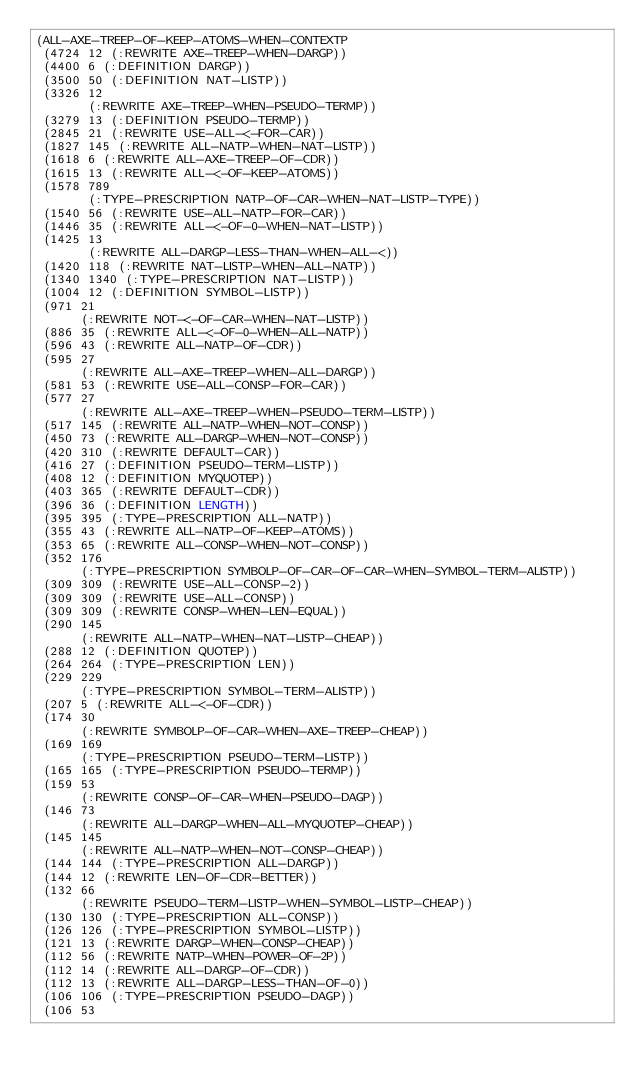Convert code to text. <code><loc_0><loc_0><loc_500><loc_500><_Lisp_>(ALL-AXE-TREEP-OF-KEEP-ATOMS-WHEN-CONTEXTP
 (4724 12 (:REWRITE AXE-TREEP-WHEN-DARGP))
 (4400 6 (:DEFINITION DARGP))
 (3500 50 (:DEFINITION NAT-LISTP))
 (3326 12
       (:REWRITE AXE-TREEP-WHEN-PSEUDO-TERMP))
 (3279 13 (:DEFINITION PSEUDO-TERMP))
 (2845 21 (:REWRITE USE-ALL-<-FOR-CAR))
 (1827 145 (:REWRITE ALL-NATP-WHEN-NAT-LISTP))
 (1618 6 (:REWRITE ALL-AXE-TREEP-OF-CDR))
 (1615 13 (:REWRITE ALL-<-OF-KEEP-ATOMS))
 (1578 789
       (:TYPE-PRESCRIPTION NATP-OF-CAR-WHEN-NAT-LISTP-TYPE))
 (1540 56 (:REWRITE USE-ALL-NATP-FOR-CAR))
 (1446 35 (:REWRITE ALL-<-OF-0-WHEN-NAT-LISTP))
 (1425 13
       (:REWRITE ALL-DARGP-LESS-THAN-WHEN-ALL-<))
 (1420 118 (:REWRITE NAT-LISTP-WHEN-ALL-NATP))
 (1340 1340 (:TYPE-PRESCRIPTION NAT-LISTP))
 (1004 12 (:DEFINITION SYMBOL-LISTP))
 (971 21
      (:REWRITE NOT-<-OF-CAR-WHEN-NAT-LISTP))
 (886 35 (:REWRITE ALL-<-OF-0-WHEN-ALL-NATP))
 (596 43 (:REWRITE ALL-NATP-OF-CDR))
 (595 27
      (:REWRITE ALL-AXE-TREEP-WHEN-ALL-DARGP))
 (581 53 (:REWRITE USE-ALL-CONSP-FOR-CAR))
 (577 27
      (:REWRITE ALL-AXE-TREEP-WHEN-PSEUDO-TERM-LISTP))
 (517 145 (:REWRITE ALL-NATP-WHEN-NOT-CONSP))
 (450 73 (:REWRITE ALL-DARGP-WHEN-NOT-CONSP))
 (420 310 (:REWRITE DEFAULT-CAR))
 (416 27 (:DEFINITION PSEUDO-TERM-LISTP))
 (408 12 (:DEFINITION MYQUOTEP))
 (403 365 (:REWRITE DEFAULT-CDR))
 (396 36 (:DEFINITION LENGTH))
 (395 395 (:TYPE-PRESCRIPTION ALL-NATP))
 (355 43 (:REWRITE ALL-NATP-OF-KEEP-ATOMS))
 (353 65 (:REWRITE ALL-CONSP-WHEN-NOT-CONSP))
 (352 176
      (:TYPE-PRESCRIPTION SYMBOLP-OF-CAR-OF-CAR-WHEN-SYMBOL-TERM-ALISTP))
 (309 309 (:REWRITE USE-ALL-CONSP-2))
 (309 309 (:REWRITE USE-ALL-CONSP))
 (309 309 (:REWRITE CONSP-WHEN-LEN-EQUAL))
 (290 145
      (:REWRITE ALL-NATP-WHEN-NAT-LISTP-CHEAP))
 (288 12 (:DEFINITION QUOTEP))
 (264 264 (:TYPE-PRESCRIPTION LEN))
 (229 229
      (:TYPE-PRESCRIPTION SYMBOL-TERM-ALISTP))
 (207 5 (:REWRITE ALL-<-OF-CDR))
 (174 30
      (:REWRITE SYMBOLP-OF-CAR-WHEN-AXE-TREEP-CHEAP))
 (169 169
      (:TYPE-PRESCRIPTION PSEUDO-TERM-LISTP))
 (165 165 (:TYPE-PRESCRIPTION PSEUDO-TERMP))
 (159 53
      (:REWRITE CONSP-OF-CAR-WHEN-PSEUDO-DAGP))
 (146 73
      (:REWRITE ALL-DARGP-WHEN-ALL-MYQUOTEP-CHEAP))
 (145 145
      (:REWRITE ALL-NATP-WHEN-NOT-CONSP-CHEAP))
 (144 144 (:TYPE-PRESCRIPTION ALL-DARGP))
 (144 12 (:REWRITE LEN-OF-CDR-BETTER))
 (132 66
      (:REWRITE PSEUDO-TERM-LISTP-WHEN-SYMBOL-LISTP-CHEAP))
 (130 130 (:TYPE-PRESCRIPTION ALL-CONSP))
 (126 126 (:TYPE-PRESCRIPTION SYMBOL-LISTP))
 (121 13 (:REWRITE DARGP-WHEN-CONSP-CHEAP))
 (112 56 (:REWRITE NATP-WHEN-POWER-OF-2P))
 (112 14 (:REWRITE ALL-DARGP-OF-CDR))
 (112 13 (:REWRITE ALL-DARGP-LESS-THAN-OF-0))
 (106 106 (:TYPE-PRESCRIPTION PSEUDO-DAGP))
 (106 53</code> 